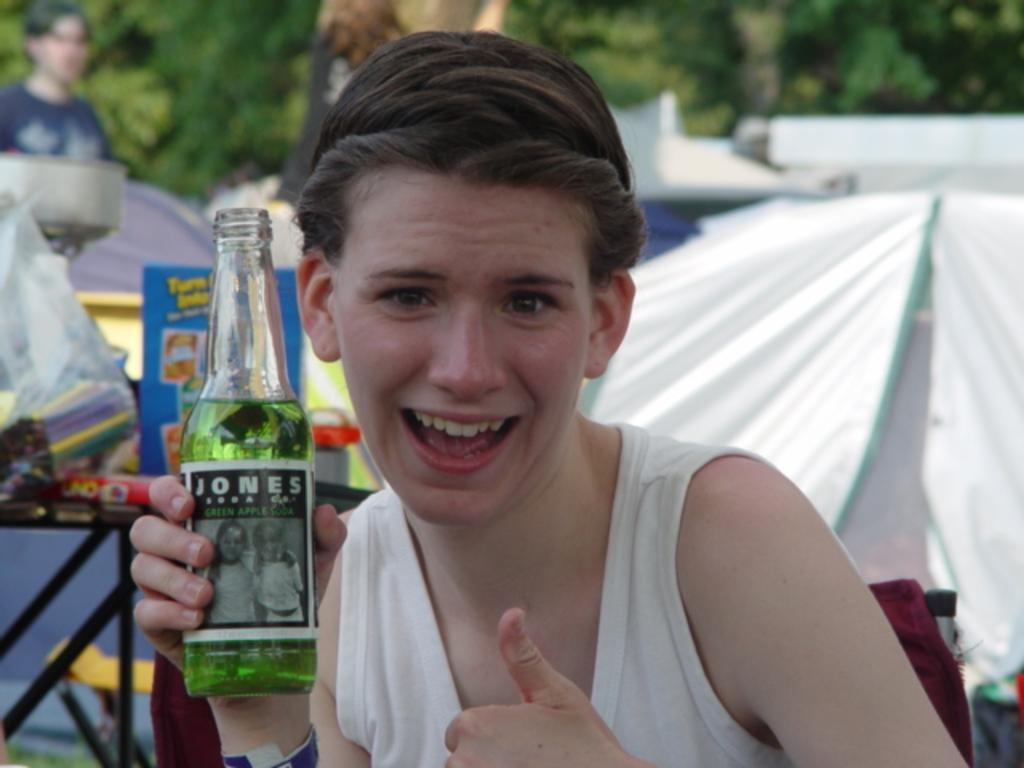What is the person in the image holding? The person is holding a bottle in the image. Can you describe the bottle? The bottle has a label. What else can be seen in the image besides the person holding the bottle? There are other things visible in the image, but the specifics are not mentioned in the facts. How many persons are standing in the image? There are persons standing in the image, but the exact number is not mentioned in the facts. What can be seen in the background of the image? Trees are present in the background of the image. What advice does the person holding the bottle give to the plane in the image? There is no plane present in the image, so no advice can be given to a plane. 